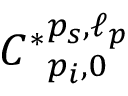<formula> <loc_0><loc_0><loc_500><loc_500>{ C ^ { * } } _ { p _ { i } , 0 } ^ { p _ { s } , \ell _ { p } }</formula> 